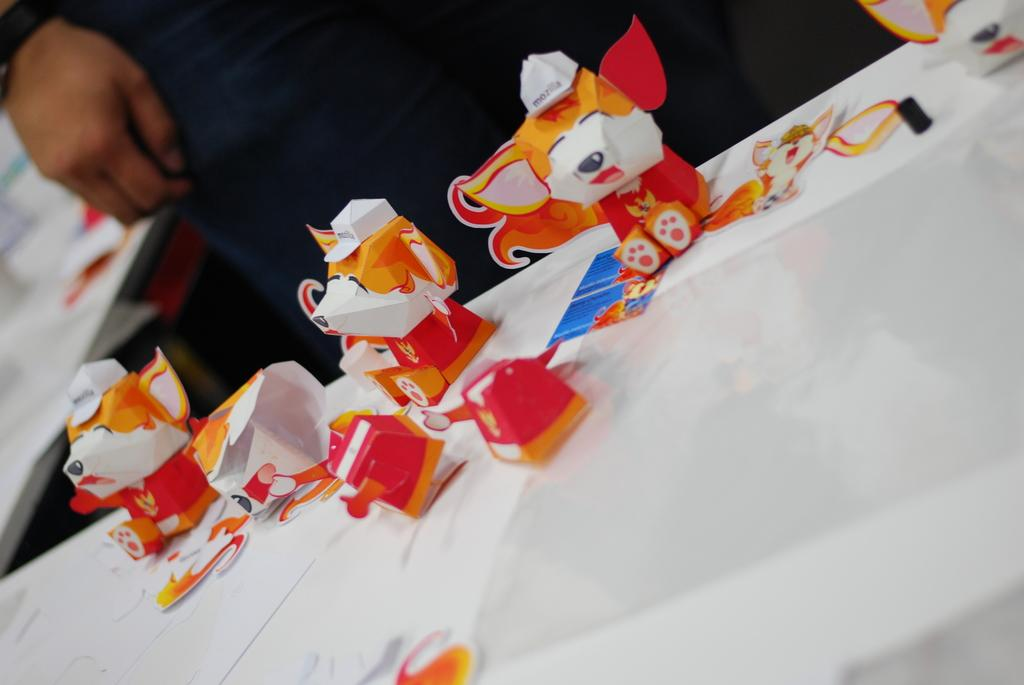What is the main object in the image? There is a table in the image. What is on the table? There are toys on the table. Is there anyone in the image? Yes, there is a person standing in the image. What type of lip balm is the person holding in the image? There is no lip balm present in the image; the person is not holding anything. 